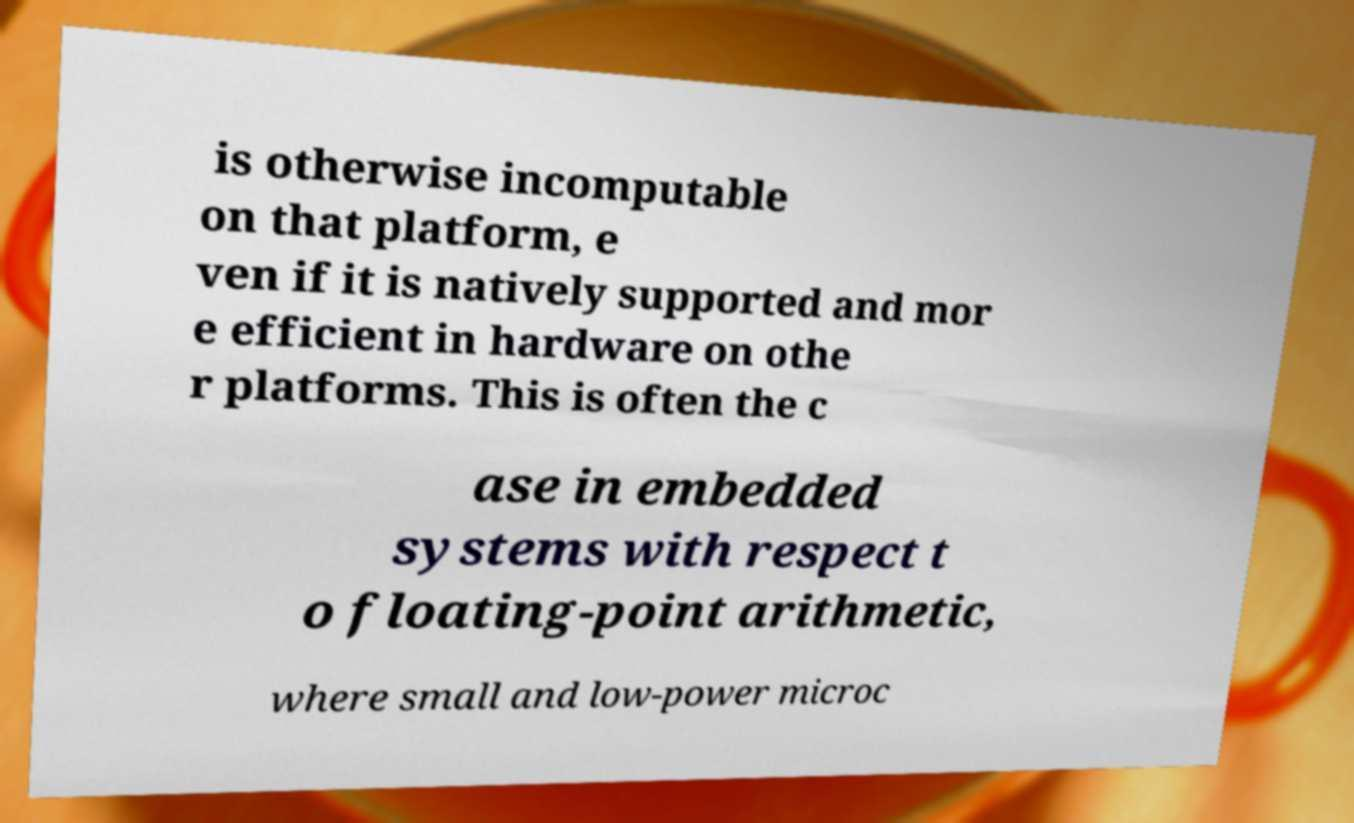What messages or text are displayed in this image? I need them in a readable, typed format. is otherwise incomputable on that platform, e ven if it is natively supported and mor e efficient in hardware on othe r platforms. This is often the c ase in embedded systems with respect t o floating-point arithmetic, where small and low-power microc 